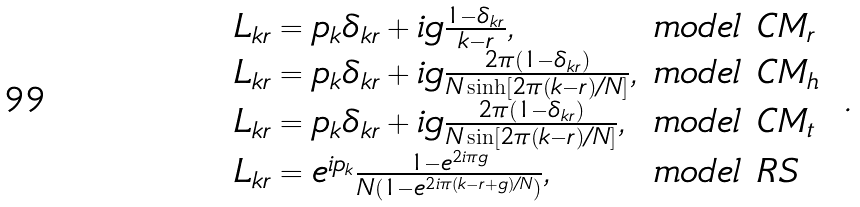Convert formula to latex. <formula><loc_0><loc_0><loc_500><loc_500>\begin{array} { l l } L _ { k r } = p _ { k } \delta _ { k r } + i g \frac { 1 - \delta _ { k r } } { k - r } , & m o d e l \ C M _ { r } \\ L _ { k r } = p _ { k } \delta _ { k r } + i g \frac { 2 \pi ( 1 - \delta _ { k r } ) } { N \sinh \left [ 2 \pi ( k - r ) / N \right ] } , & m o d e l \ C M _ { h } \\ L _ { k r } = p _ { k } \delta _ { k r } + i g \frac { 2 \pi ( 1 - \delta _ { k r } ) } { N \sin \left [ 2 \pi ( k - r ) / N \right ] } , & m o d e l \ C M _ { t } \\ L _ { k r } = e ^ { i p _ { k } } \frac { 1 - e ^ { 2 i \pi g } } { N ( 1 - e ^ { 2 i \pi ( k - r + g ) / N } ) } , & m o d e l \ R S \, \end{array} \ .</formula> 